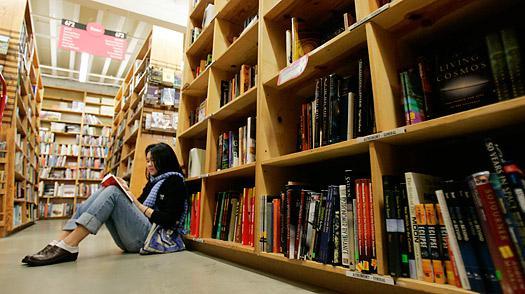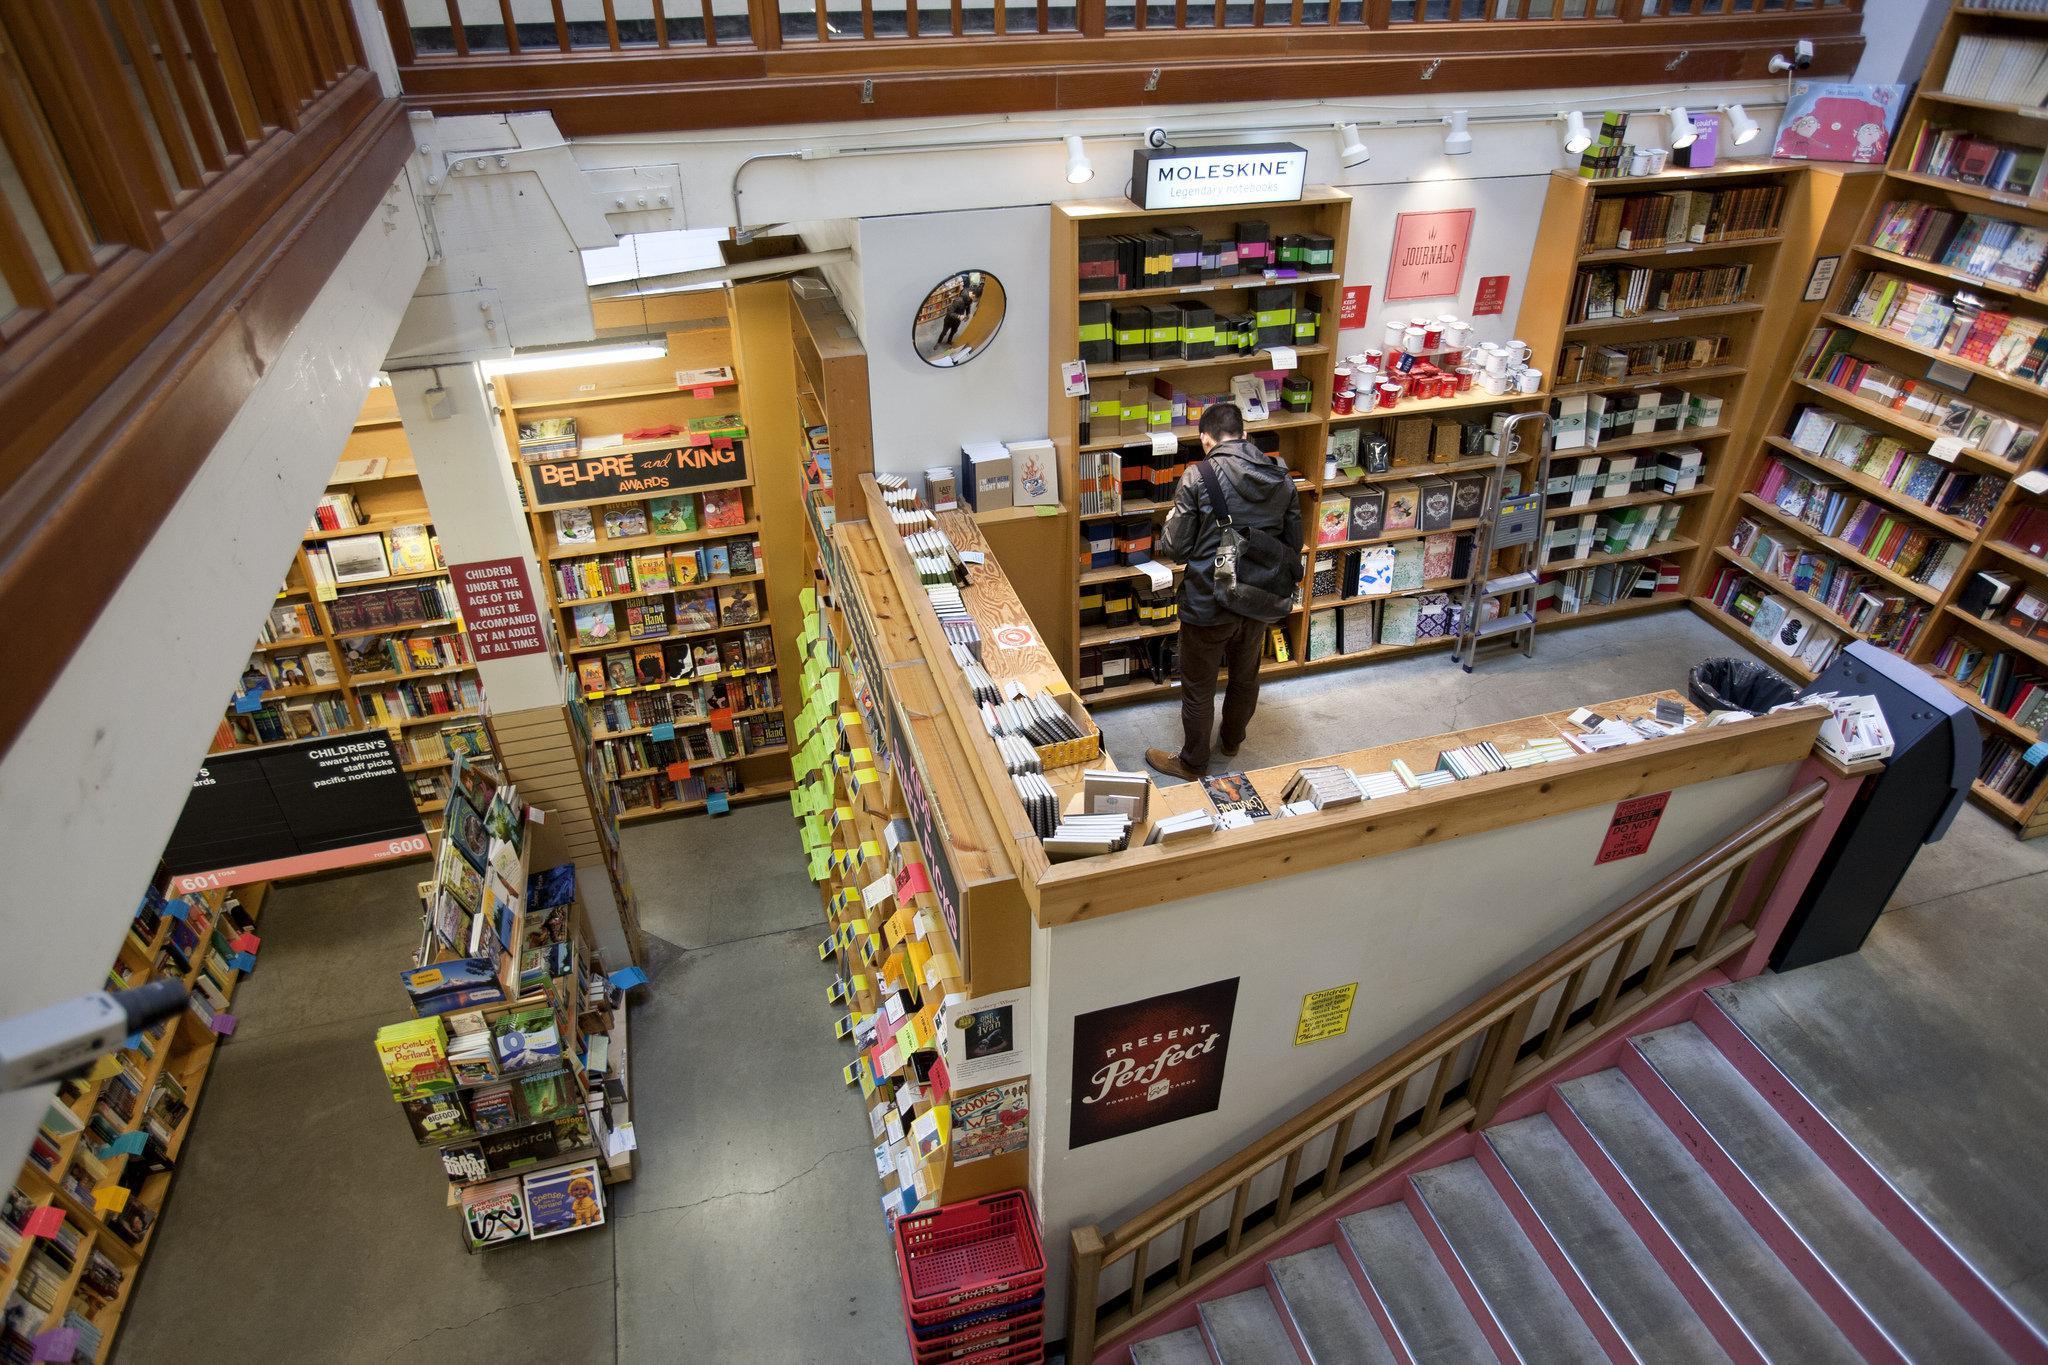The first image is the image on the left, the second image is the image on the right. Considering the images on both sides, is "There is a single woman with black hair who has sat down to read near at least one other shelf of books." valid? Answer yes or no. Yes. The first image is the image on the left, the second image is the image on the right. Examine the images to the left and right. Is the description "A person is sitting down." accurate? Answer yes or no. Yes. 